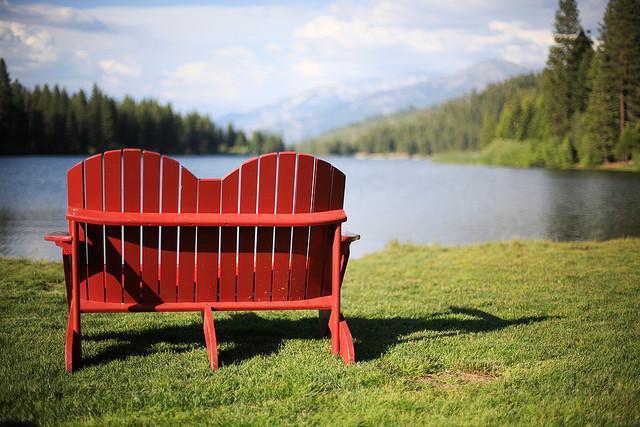How many people would fit on this bench?
Give a very brief answer. 2. 